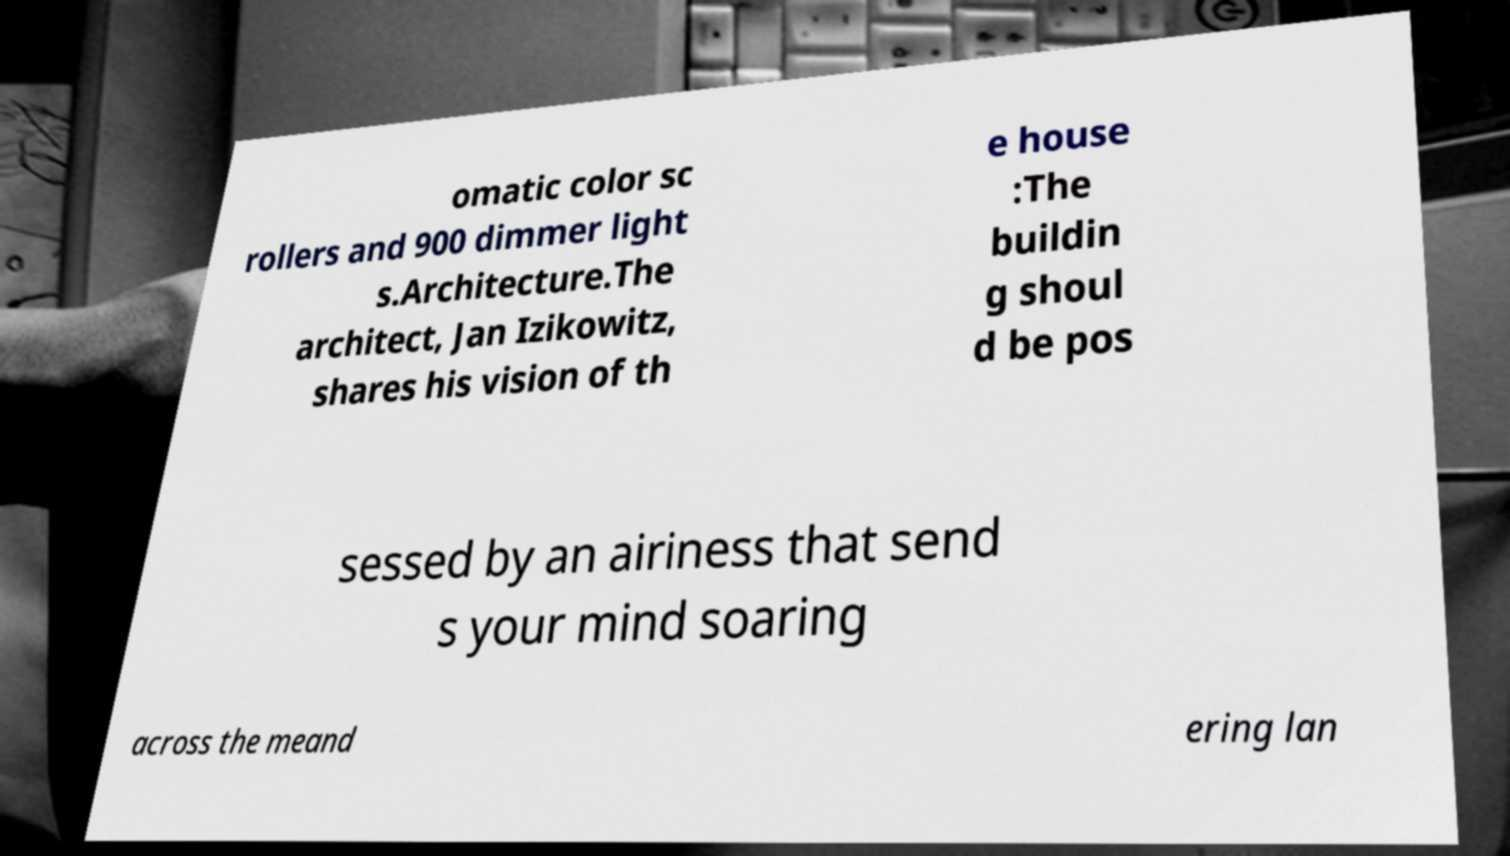Please identify and transcribe the text found in this image. omatic color sc rollers and 900 dimmer light s.Architecture.The architect, Jan Izikowitz, shares his vision of th e house :The buildin g shoul d be pos sessed by an airiness that send s your mind soaring across the meand ering lan 